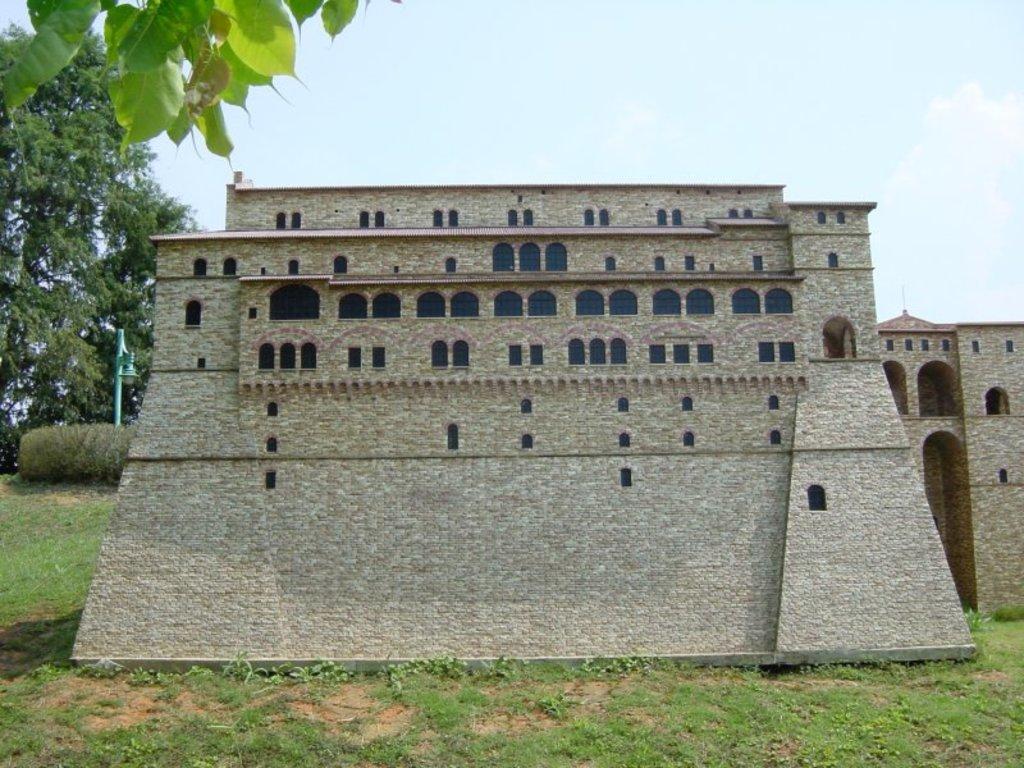Could you give a brief overview of what you see in this image? In the center of the image there is a building with windows. At the bottom of the image there is grass. In the background of the image there are trees and sky. There is a light pole. 